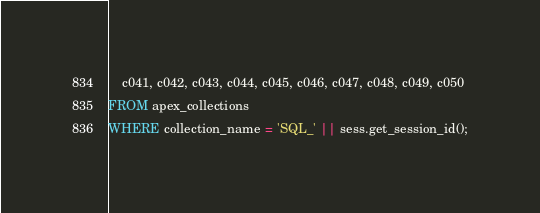Convert code to text. <code><loc_0><loc_0><loc_500><loc_500><_SQL_>    c041, c042, c043, c044, c045, c046, c047, c048, c049, c050
FROM apex_collections
WHERE collection_name = 'SQL_' || sess.get_session_id();


</code> 